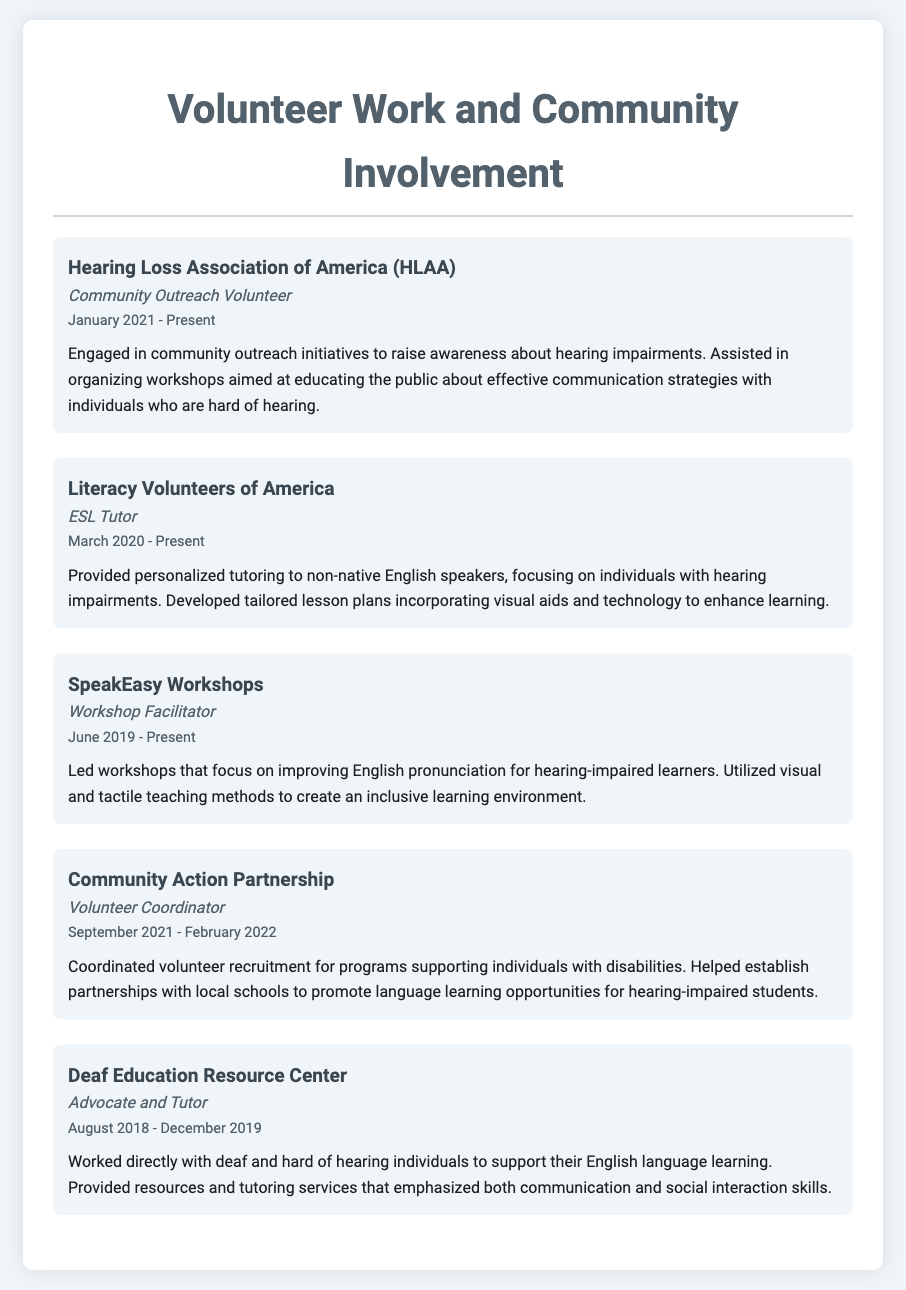what organization did the community outreach volunteer work for? The organization mentioned in the document for community outreach volunteer work is the Hearing Loss Association of America.
Answer: Hearing Loss Association of America when did the ESL tutoring start? The ESL tutoring began in March 2020 according to the document.
Answer: March 2020 what role did the person have at SpeakEasy Workshops? The document states that the person's role at SpeakEasy Workshops was Workshop Facilitator.
Answer: Workshop Facilitator how long did the person serve as a Volunteer Coordinator? The duration of service as a Volunteer Coordinator is specified as from September 2021 to February 2022, totaling five months.
Answer: five months which methods were utilized in workshops for hearing-impaired learners? The document indicates that visual and tactile teaching methods were utilized in workshops for hearing-impaired learners.
Answer: visual and tactile teaching methods how many volunteer experiences are listed in the document? The total number of volunteer experiences listed in the document is five.
Answer: five what was the focus of the tutoring offered to non-native English speakers? The tutoring provided focused on individuals with hearing impairments according to the description.
Answer: individuals with hearing impairments which organization partnered with local schools for language learning opportunities? The organization that partnered with local schools mentioned in the document is Community Action Partnership.
Answer: Community Action Partnership 